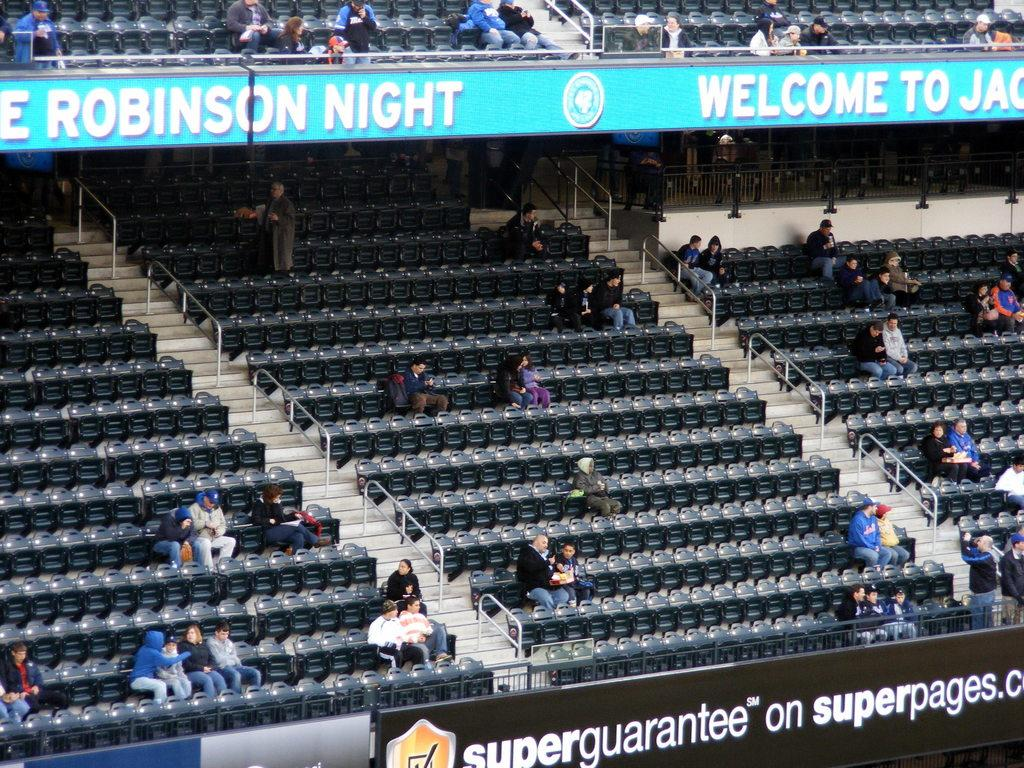What type of structure is shown in the image? There is a stadium in the image. What can be seen inside the stadium? There are people sitting in the seats in the stadium. Can you describe the gender distribution of the people in the image? Both men and women are visible in the image. How full is the stadium in the image? Most of the seats in the stadium are empty. What type of cord is being used by the cow in the image? There is no cow present in the image, so there is no cord being used. 